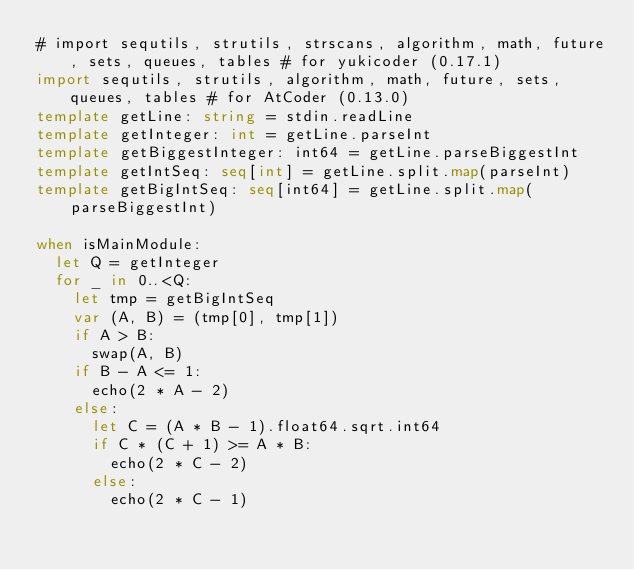Convert code to text. <code><loc_0><loc_0><loc_500><loc_500><_Nim_># import sequtils, strutils, strscans, algorithm, math, future, sets, queues, tables # for yukicoder (0.17.1)
import sequtils, strutils, algorithm, math, future, sets, queues, tables # for AtCoder (0.13.0)
template getLine: string = stdin.readLine
template getInteger: int = getLine.parseInt
template getBiggestInteger: int64 = getLine.parseBiggestInt
template getIntSeq: seq[int] = getLine.split.map(parseInt)
template getBigIntSeq: seq[int64] = getLine.split.map(parseBiggestInt)

when isMainModule:
  let Q = getInteger
  for _ in 0..<Q:
    let tmp = getBigIntSeq
    var (A, B) = (tmp[0], tmp[1])
    if A > B:
      swap(A, B)
    if B - A <= 1:
      echo(2 * A - 2)
    else:
      let C = (A * B - 1).float64.sqrt.int64
      if C * (C + 1) >= A * B:
        echo(2 * C - 2)
      else:
        echo(2 * C - 1)
</code> 